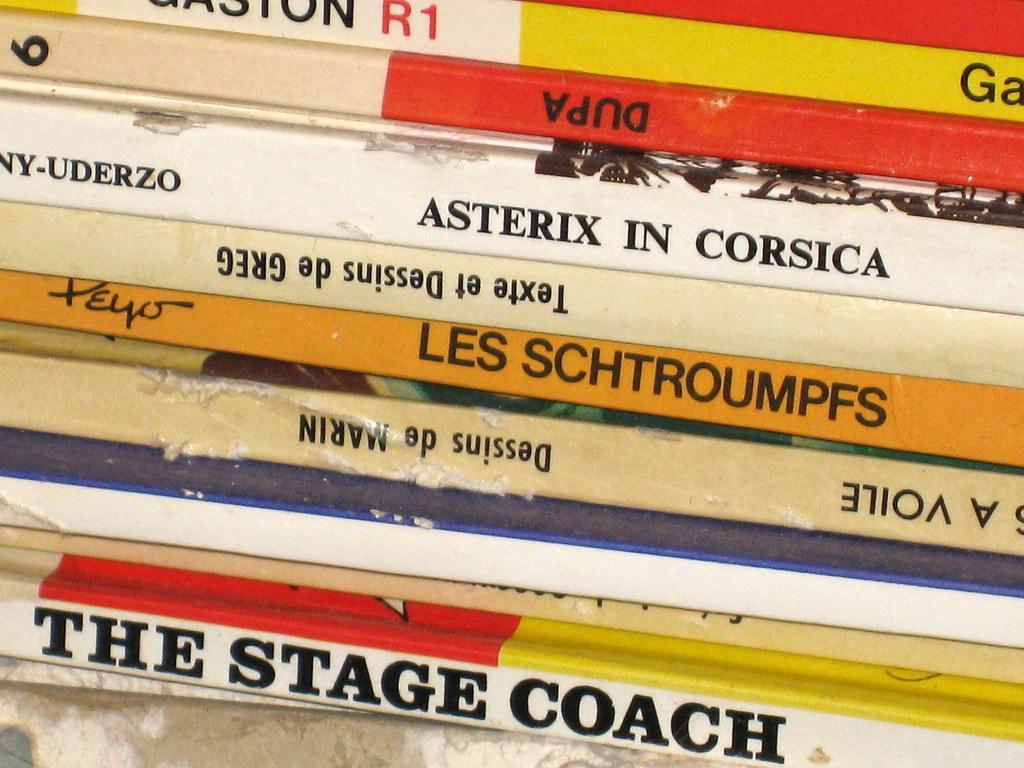In one or two sentences, can you explain what this image depicts? In this image we can see books placed in a row. 